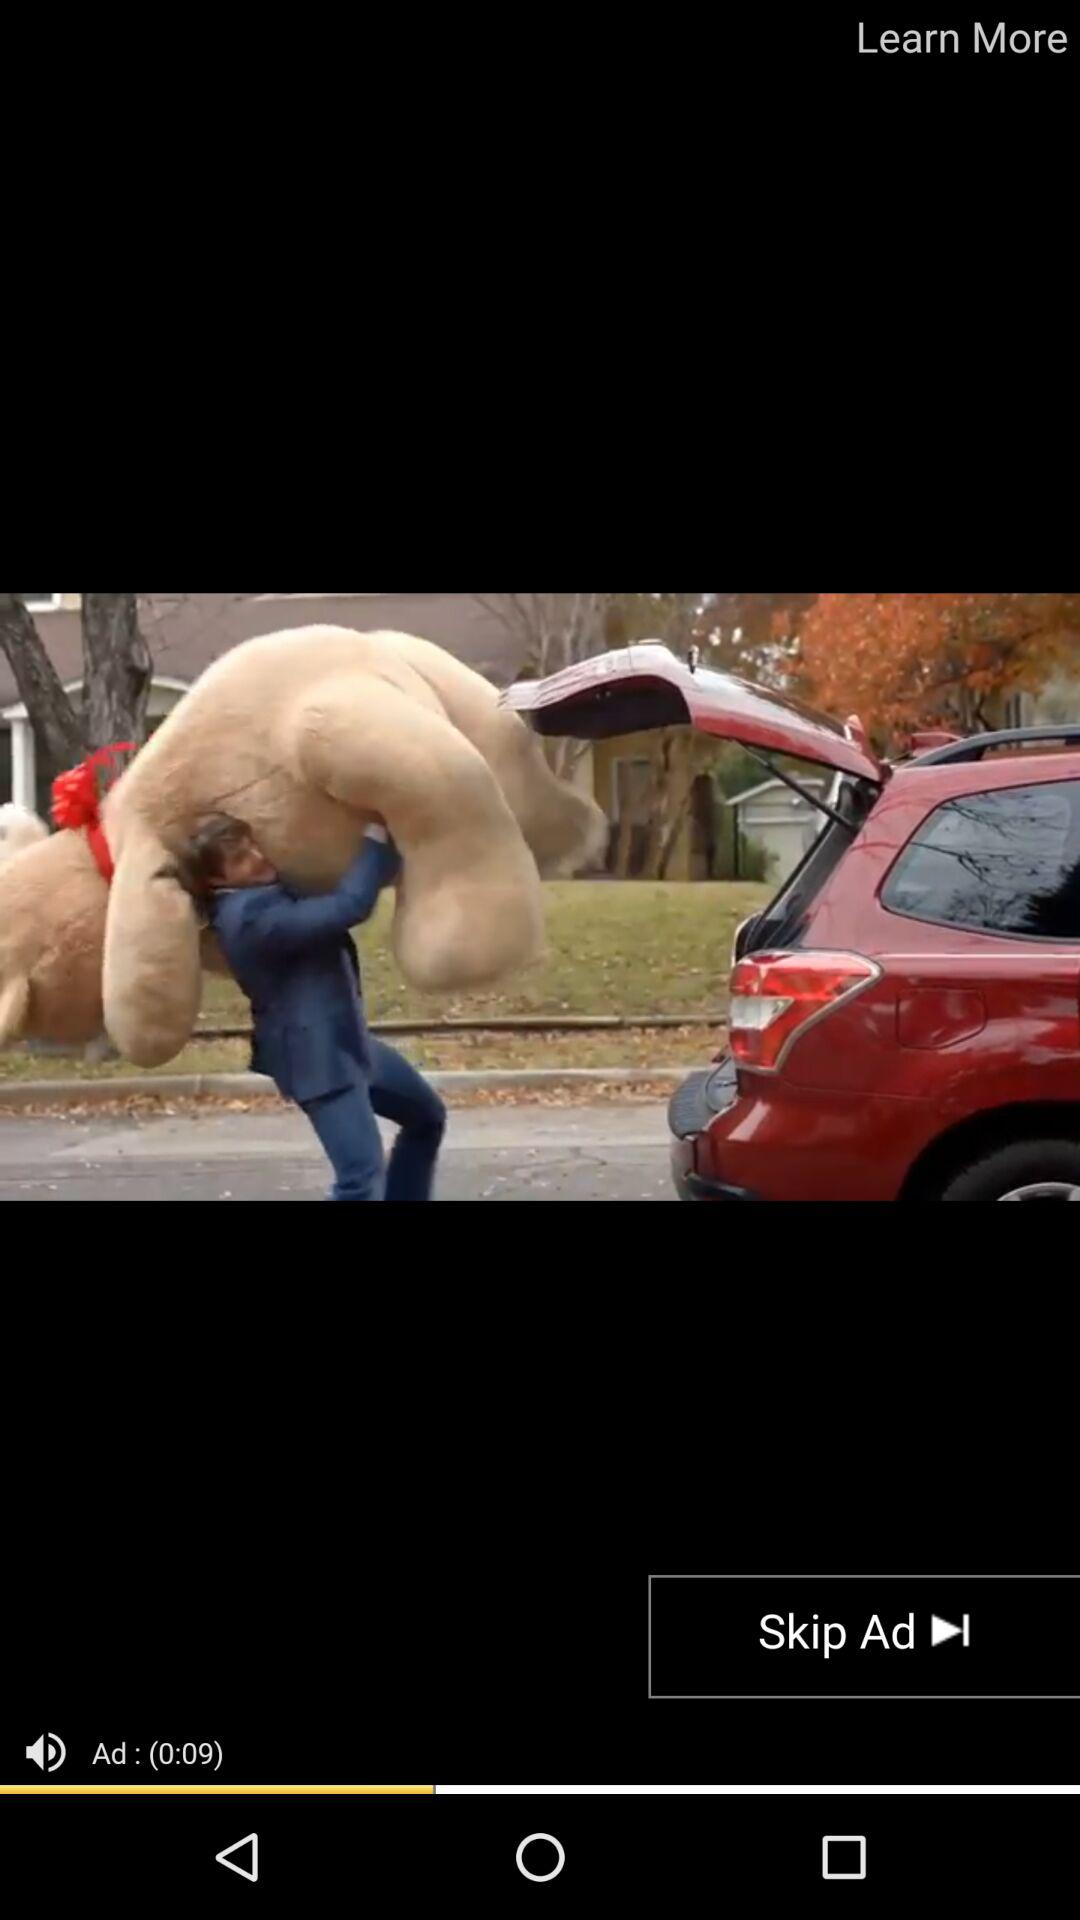How many seconds long is the ad?
Answer the question using a single word or phrase. 9 